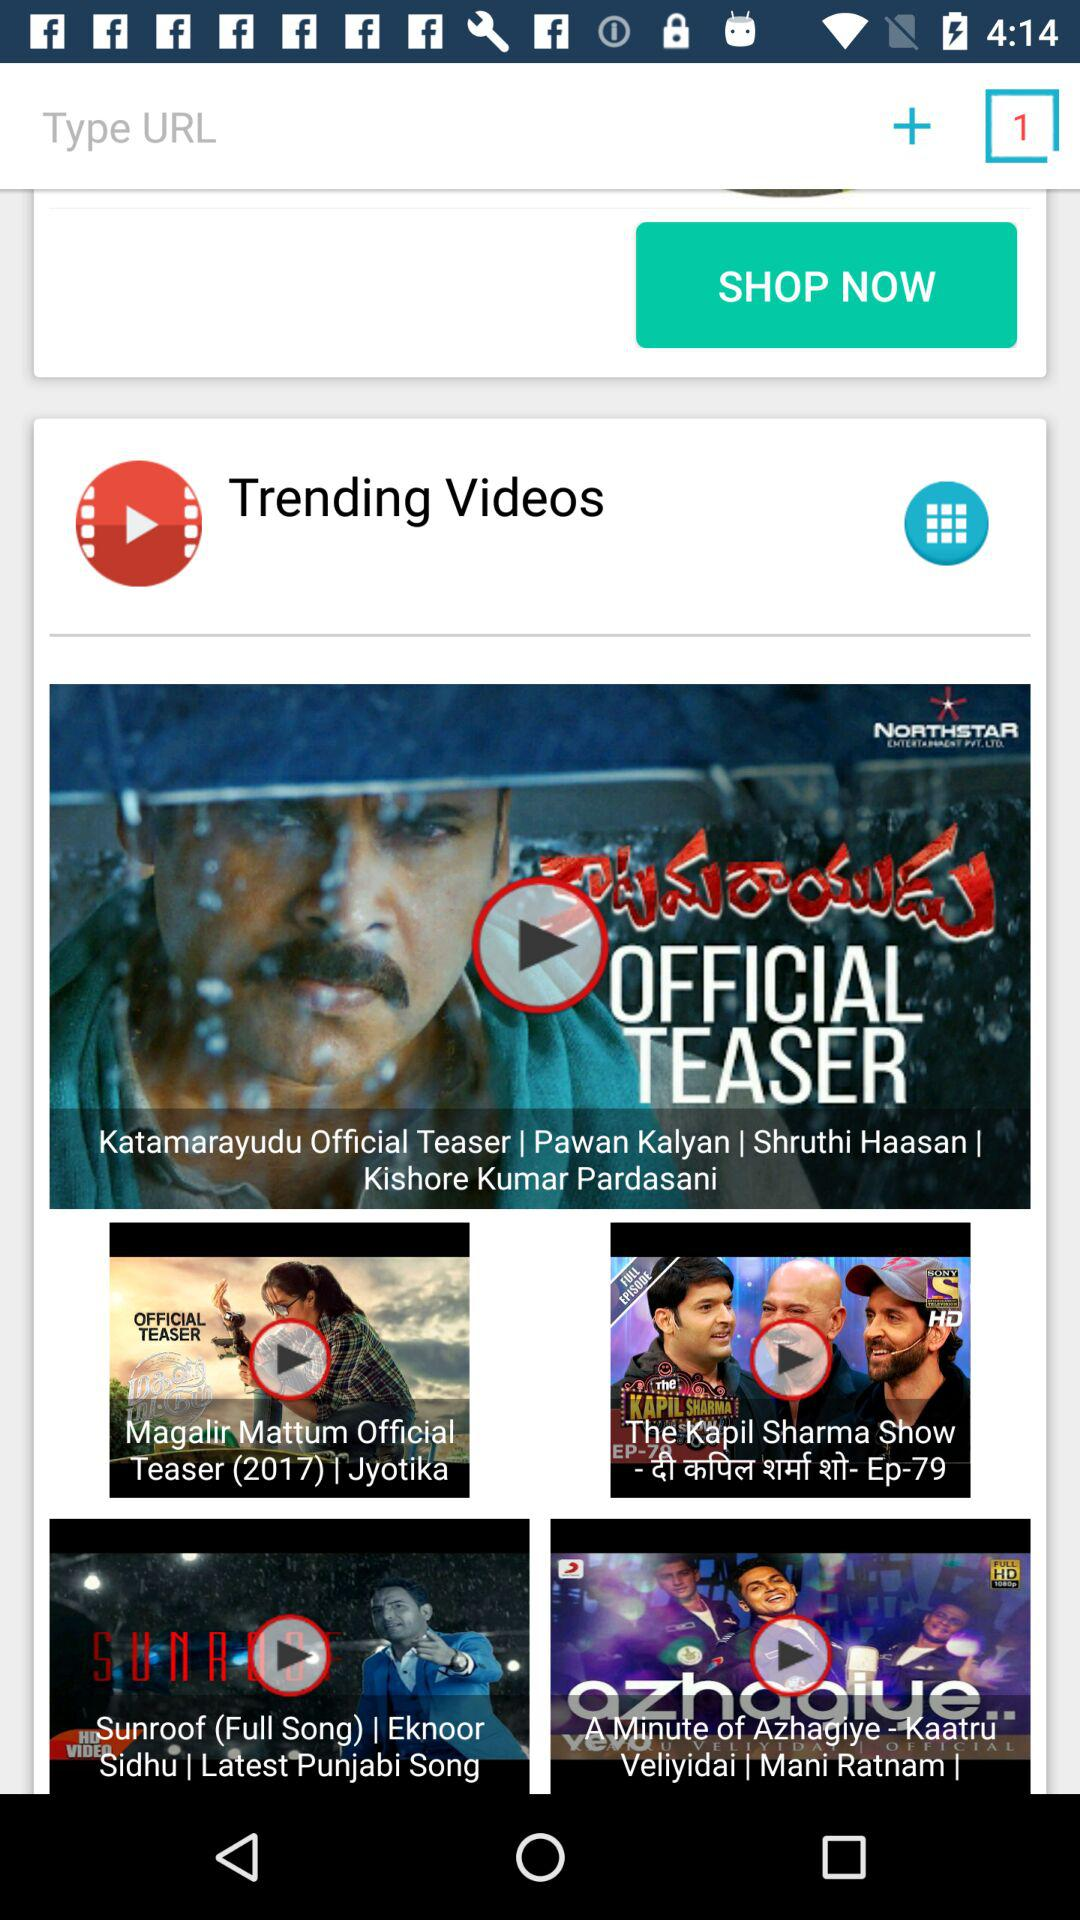What are the titles of a few of the trending videos? The titles are "Katamarayudu Official Teaser", "Magalir Mattum Official Teaser (2017) | Jyotika", "The Kapil Sharma Show", "Sunroof", and "A Minute of Azhagiye". 